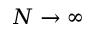Convert formula to latex. <formula><loc_0><loc_0><loc_500><loc_500>N \rightarrow \infty</formula> 